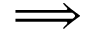<formula> <loc_0><loc_0><loc_500><loc_500>\Longrightarrow</formula> 